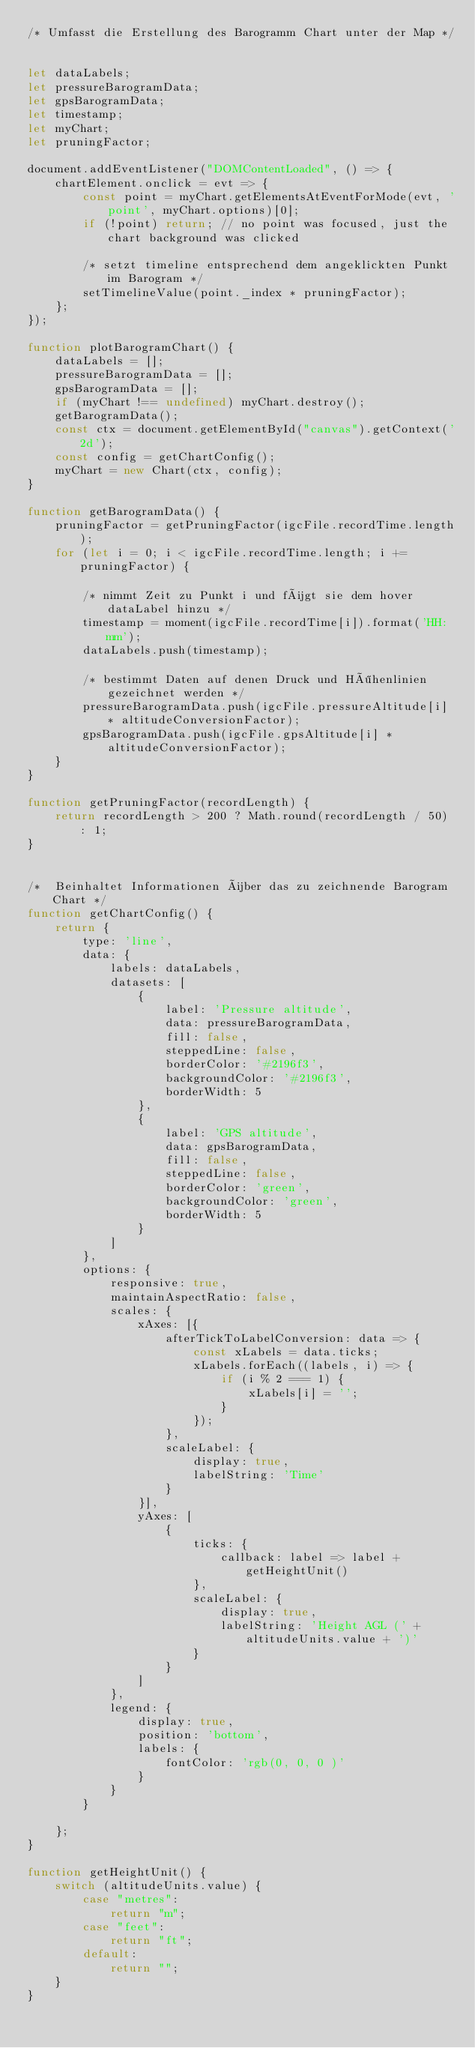<code> <loc_0><loc_0><loc_500><loc_500><_JavaScript_>/* Umfasst die Erstellung des Barogramm Chart unter der Map */


let dataLabels;
let pressureBarogramData;
let gpsBarogramData;
let timestamp;
let myChart;
let pruningFactor;

document.addEventListener("DOMContentLoaded", () => {
    chartElement.onclick = evt => {
        const point = myChart.getElementsAtEventForMode(evt, 'point', myChart.options)[0];
        if (!point) return; // no point was focused, just the chart background was clicked

        /* setzt timeline entsprechend dem angeklickten Punkt im Barogram */
        setTimelineValue(point._index * pruningFactor);
    };
});

function plotBarogramChart() {
    dataLabels = [];
    pressureBarogramData = [];
    gpsBarogramData = [];
    if (myChart !== undefined) myChart.destroy();
    getBarogramData();
    const ctx = document.getElementById("canvas").getContext('2d');
    const config = getChartConfig();
    myChart = new Chart(ctx, config);
}

function getBarogramData() {
    pruningFactor = getPruningFactor(igcFile.recordTime.length);
    for (let i = 0; i < igcFile.recordTime.length; i += pruningFactor) {

        /* nimmt Zeit zu Punkt i und fügt sie dem hover dataLabel hinzu */
        timestamp = moment(igcFile.recordTime[i]).format('HH:mm');
        dataLabels.push(timestamp);

        /* bestimmt Daten auf denen Druck und Höhenlinien gezeichnet werden */
        pressureBarogramData.push(igcFile.pressureAltitude[i] * altitudeConversionFactor);
        gpsBarogramData.push(igcFile.gpsAltitude[i] * altitudeConversionFactor);
    }
}

function getPruningFactor(recordLength) {
    return recordLength > 200 ? Math.round(recordLength / 50) : 1;
}


/*  Beinhaltet Informationen über das zu zeichnende Barogram Chart */
function getChartConfig() {
    return {
        type: 'line',
        data: {
            labels: dataLabels,
            datasets: [
                {
                    label: 'Pressure altitude',
                    data: pressureBarogramData,
                    fill: false,
                    steppedLine: false,
                    borderColor: '#2196f3',
                    backgroundColor: '#2196f3',
                    borderWidth: 5
                },
                {
                    label: 'GPS altitude',
                    data: gpsBarogramData,
                    fill: false,
                    steppedLine: false,
                    borderColor: 'green',
                    backgroundColor: 'green',
                    borderWidth: 5
                }
            ]
        },
        options: {
            responsive: true,
            maintainAspectRatio: false,
            scales: {
                xAxes: [{
                    afterTickToLabelConversion: data => {
                        const xLabels = data.ticks;
                        xLabels.forEach((labels, i) => {
                            if (i % 2 === 1) {
                                xLabels[i] = '';
                            }
                        });
                    },
                    scaleLabel: {
                        display: true,
                        labelString: 'Time'
                    }
                }],
                yAxes: [
                    {
                        ticks: {
                            callback: label => label + getHeightUnit()
                        },
                        scaleLabel: {
                            display: true,
                            labelString: 'Height AGL (' + altitudeUnits.value + ')'
                        }
                    }
                ]
            },
            legend: {
                display: true,
                position: 'bottom',
                labels: {
                    fontColor: 'rgb(0, 0, 0 )'
                }
            }
        }

    };
}

function getHeightUnit() {
    switch (altitudeUnits.value) {
        case "metres":
            return "m";
        case "feet":
            return "ft";
        default:
            return "";
    }
}
</code> 